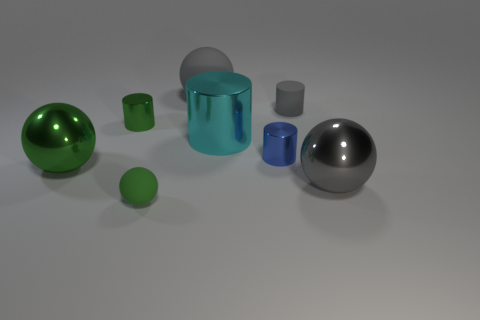Are there any large metallic balls on the left side of the tiny gray cylinder?
Provide a short and direct response. Yes. What size is the ball that is on the left side of the green object that is in front of the big object that is on the right side of the gray matte cylinder?
Offer a very short reply. Large. Do the gray matte object in front of the large matte object and the large thing left of the tiny matte sphere have the same shape?
Your answer should be compact. No. What size is the other metal object that is the same shape as the big green metal thing?
Ensure brevity in your answer.  Large. What number of small blue things have the same material as the cyan object?
Ensure brevity in your answer.  1. What is the big cyan cylinder made of?
Offer a very short reply. Metal. There is a tiny green object in front of the sphere that is to the right of the small gray rubber object; what is its shape?
Ensure brevity in your answer.  Sphere. There is a rubber object to the right of the blue metal thing; what is its shape?
Offer a terse response. Cylinder. What number of shiny spheres are the same color as the large rubber ball?
Provide a short and direct response. 1. What color is the tiny rubber sphere?
Your answer should be compact. Green. 